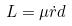Convert formula to latex. <formula><loc_0><loc_0><loc_500><loc_500>L = \mu \dot { r } d</formula> 